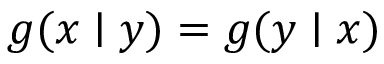Convert formula to latex. <formula><loc_0><loc_0><loc_500><loc_500>g ( x | y ) = g ( y | x )</formula> 